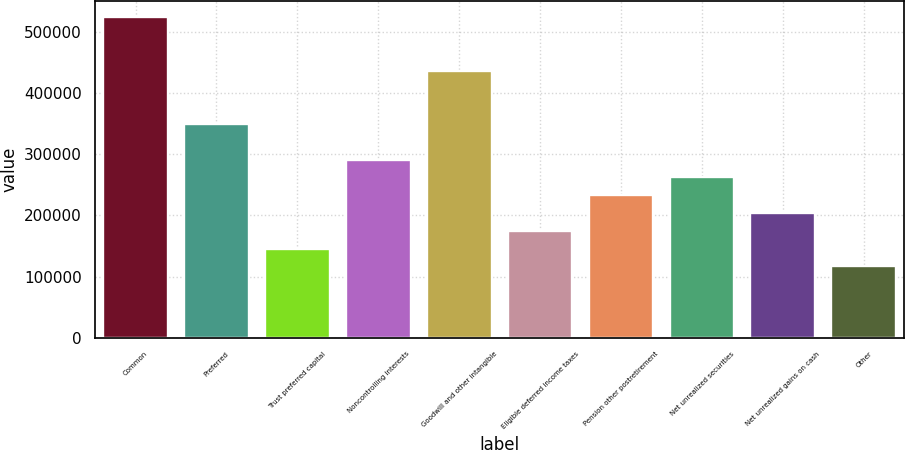Convert chart. <chart><loc_0><loc_0><loc_500><loc_500><bar_chart><fcel>Common<fcel>Preferred<fcel>Trust preferred capital<fcel>Noncontrolling interests<fcel>Goodwill and other intangible<fcel>Eligible deferred income taxes<fcel>Pension other postretirement<fcel>Net unrealized securities<fcel>Net unrealized gains on cash<fcel>Other<nl><fcel>524559<fcel>349709<fcel>145718<fcel>291426<fcel>437134<fcel>174859<fcel>233143<fcel>262284<fcel>204001<fcel>116576<nl></chart> 